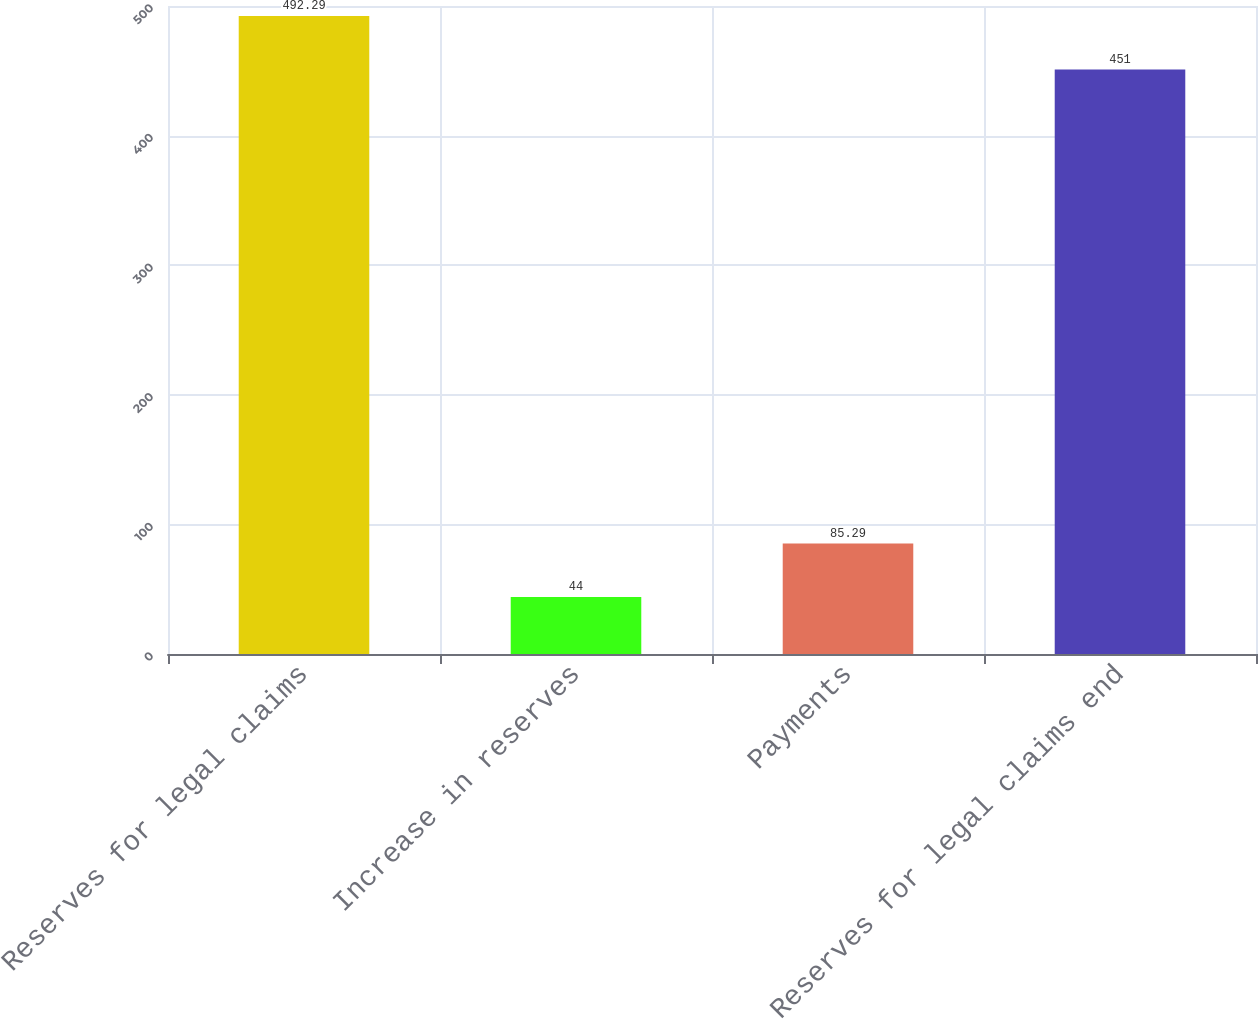Convert chart. <chart><loc_0><loc_0><loc_500><loc_500><bar_chart><fcel>Reserves for legal claims<fcel>Increase in reserves<fcel>Payments<fcel>Reserves for legal claims end<nl><fcel>492.29<fcel>44<fcel>85.29<fcel>451<nl></chart> 